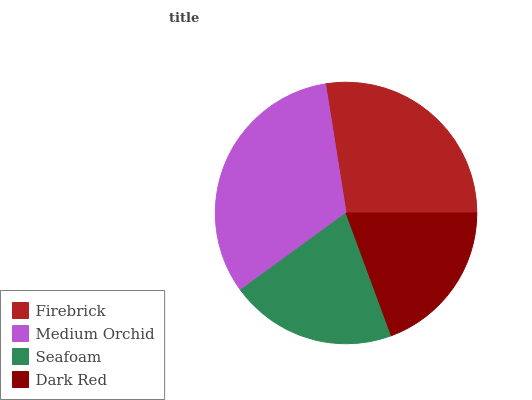Is Dark Red the minimum?
Answer yes or no. Yes. Is Medium Orchid the maximum?
Answer yes or no. Yes. Is Seafoam the minimum?
Answer yes or no. No. Is Seafoam the maximum?
Answer yes or no. No. Is Medium Orchid greater than Seafoam?
Answer yes or no. Yes. Is Seafoam less than Medium Orchid?
Answer yes or no. Yes. Is Seafoam greater than Medium Orchid?
Answer yes or no. No. Is Medium Orchid less than Seafoam?
Answer yes or no. No. Is Firebrick the high median?
Answer yes or no. Yes. Is Seafoam the low median?
Answer yes or no. Yes. Is Dark Red the high median?
Answer yes or no. No. Is Medium Orchid the low median?
Answer yes or no. No. 